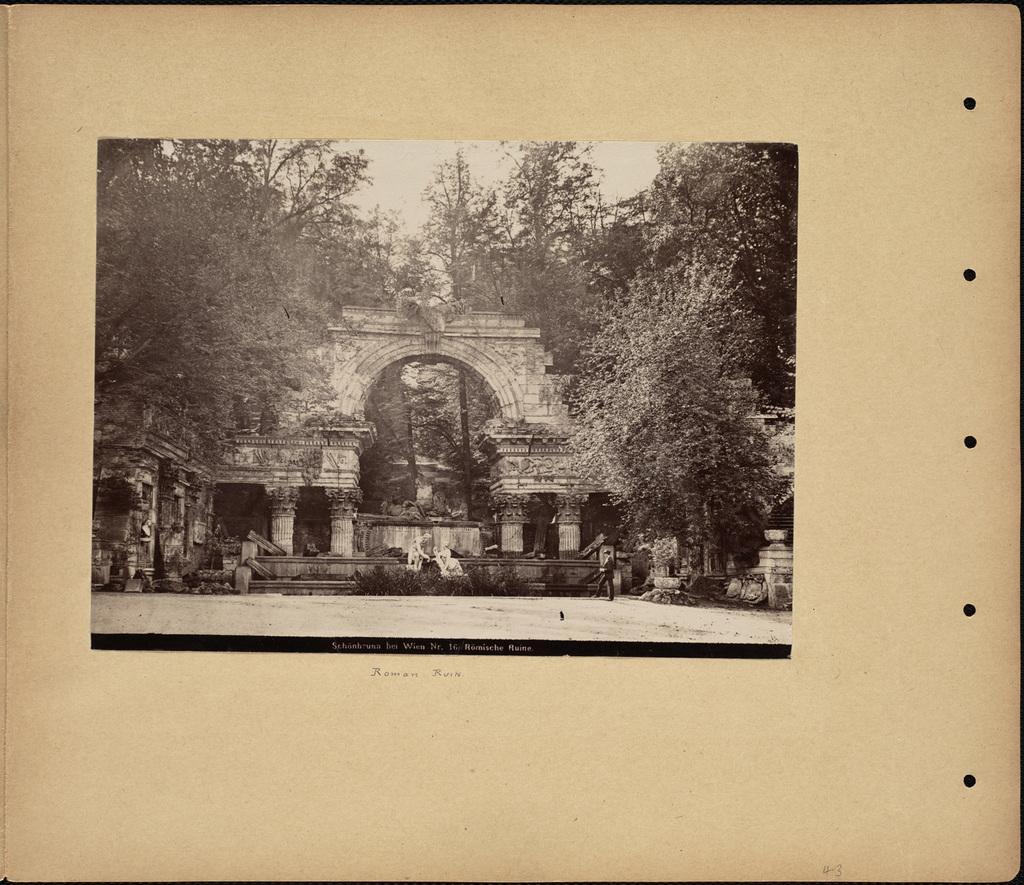Please provide a concise description of this image. This image consists of a board on which we can see a picture of an arch along with trees and pillars. 